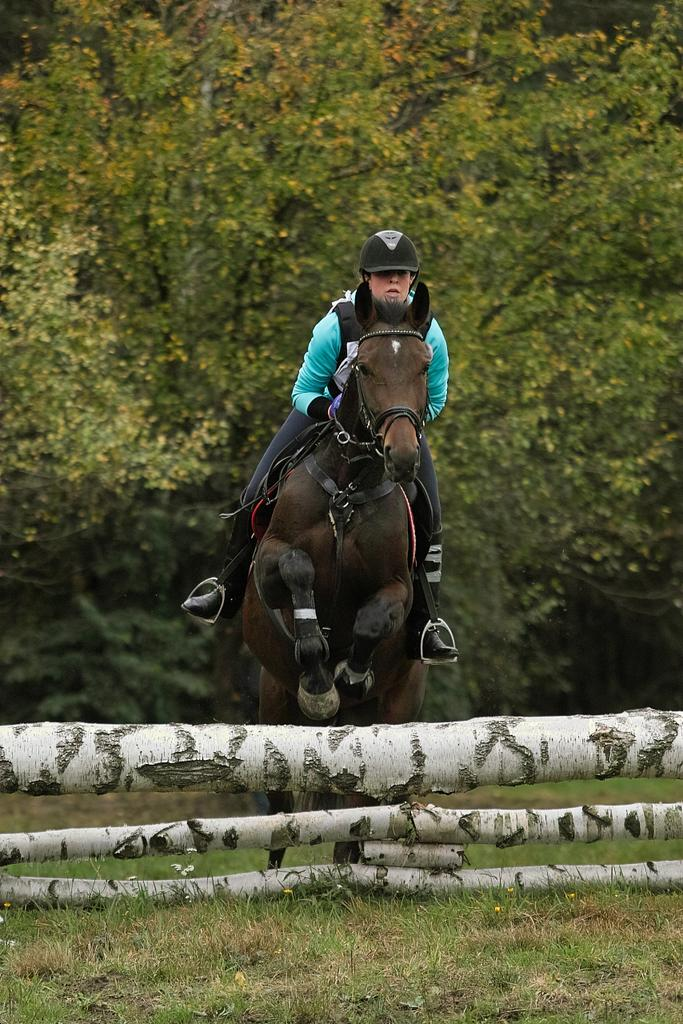What activity is the person in the image engaged in? The person is horse riding in the image. Can you describe the horse's appearance? The horse is dark brown in color. What can be seen in the middle of the image? There are trees in the middle of the image. Where is the dock located in the image? There is no dock present in the image. What type of produce can be seen growing near the trees in the image? There is no produce visible in the image; only trees are mentioned. 